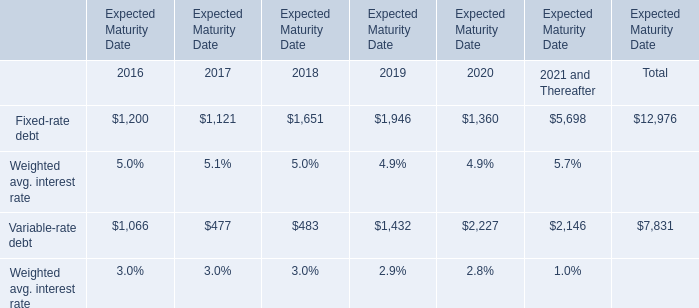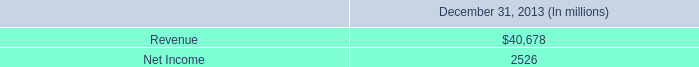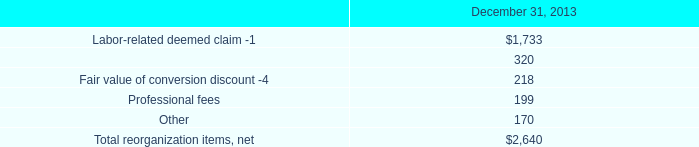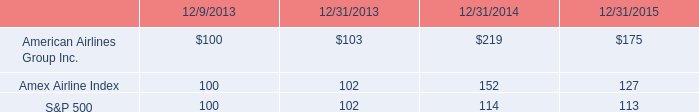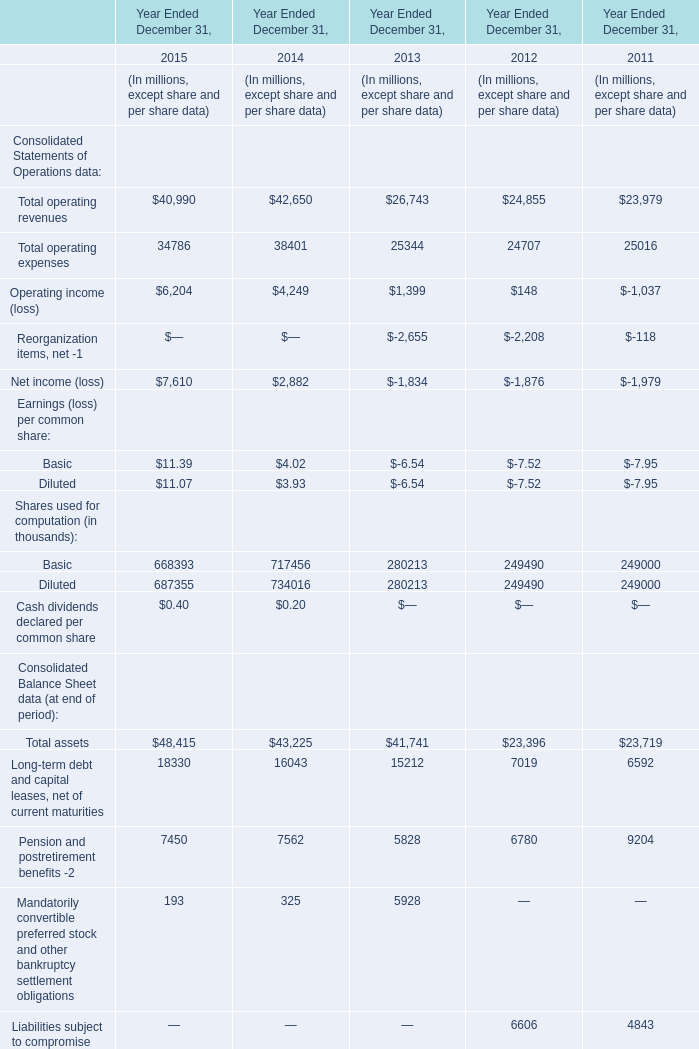Without Reorganization items, net -1 and Net income (loss), how much of Consolidated Statements of Operations data is there in total in 2015? (in million) 
Computations: ((40990 + 34786) + 6204)
Answer: 81980.0. 